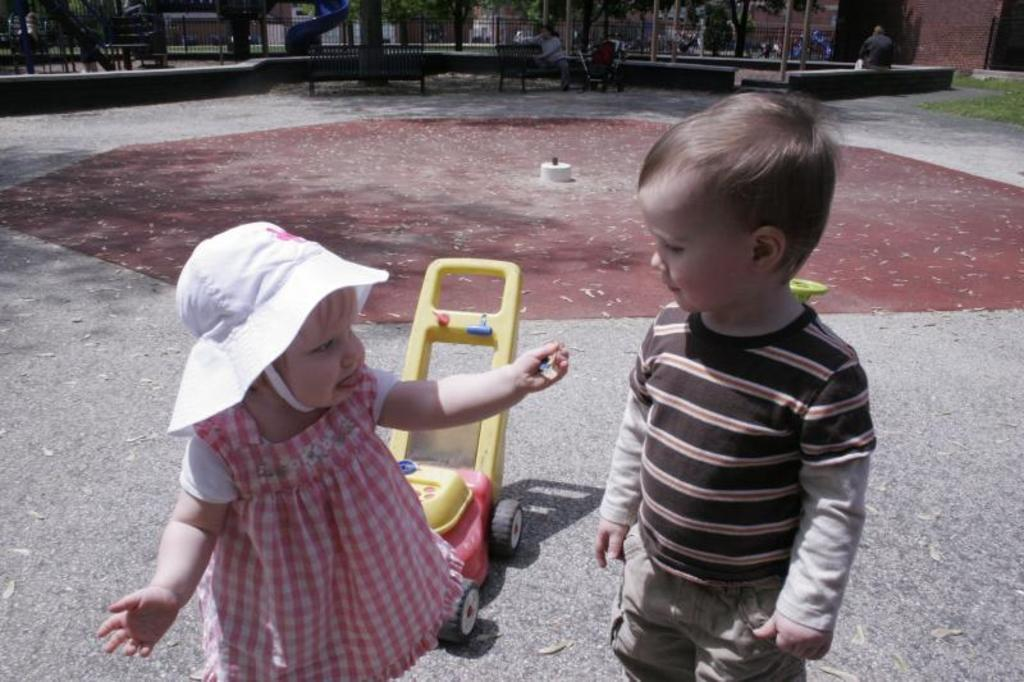How many kids are present in the image? There are two kids standing in the image. What is happening in the background of the image? There is a person sitting on a bench and a toy vehicle in the background of the image. What type of pickle is the person holding in the image? There is no pickle present in the image. What record is being played in the background of the image? There is no record player or music being played in the image. 